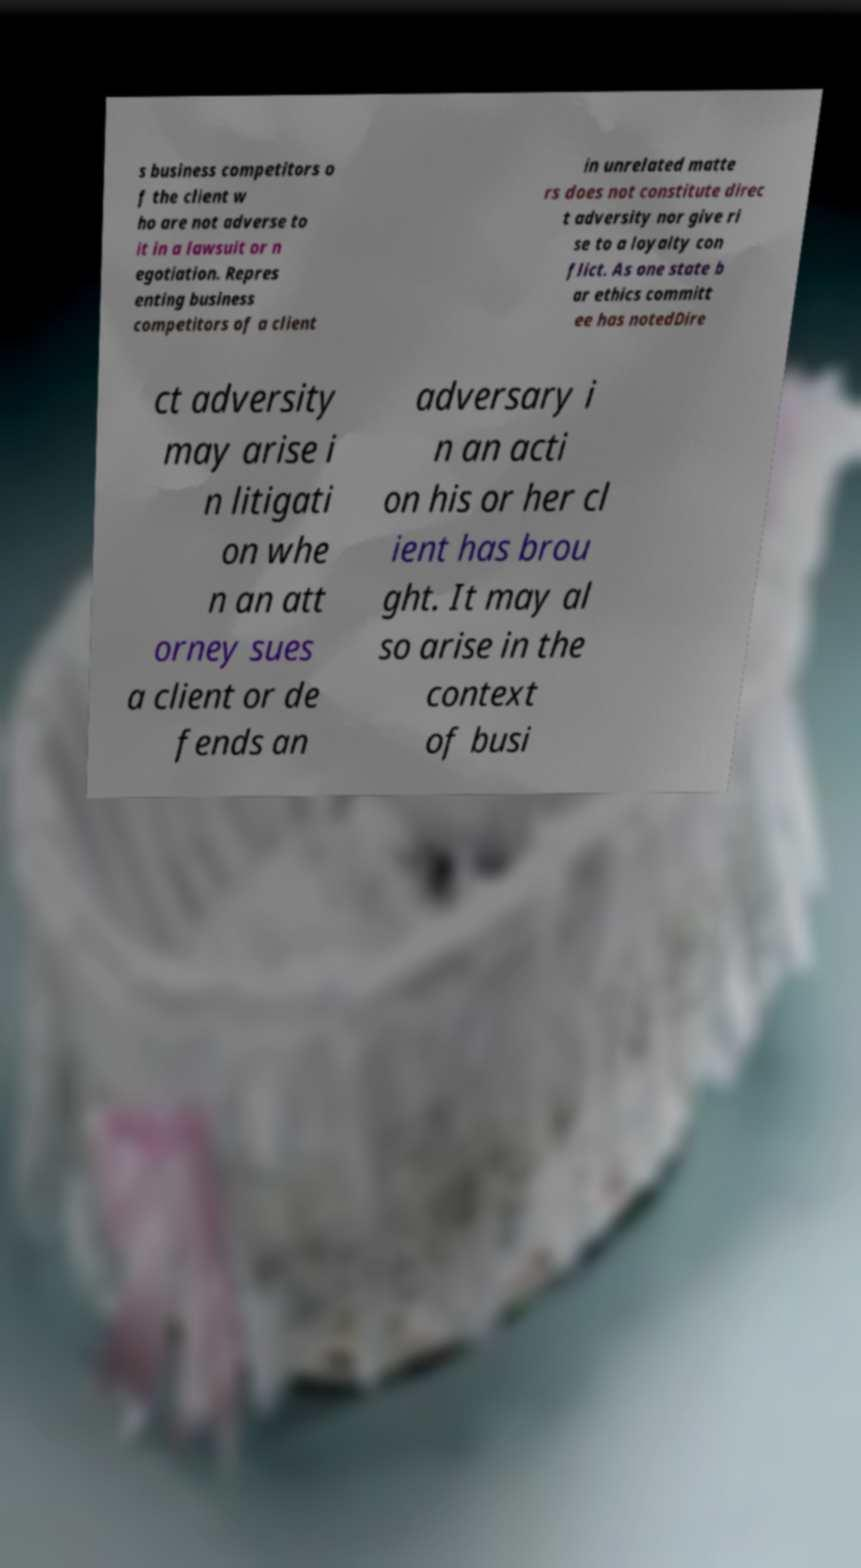Please read and relay the text visible in this image. What does it say? s business competitors o f the client w ho are not adverse to it in a lawsuit or n egotiation. Repres enting business competitors of a client in unrelated matte rs does not constitute direc t adversity nor give ri se to a loyalty con flict. As one state b ar ethics committ ee has notedDire ct adversity may arise i n litigati on whe n an att orney sues a client or de fends an adversary i n an acti on his or her cl ient has brou ght. It may al so arise in the context of busi 